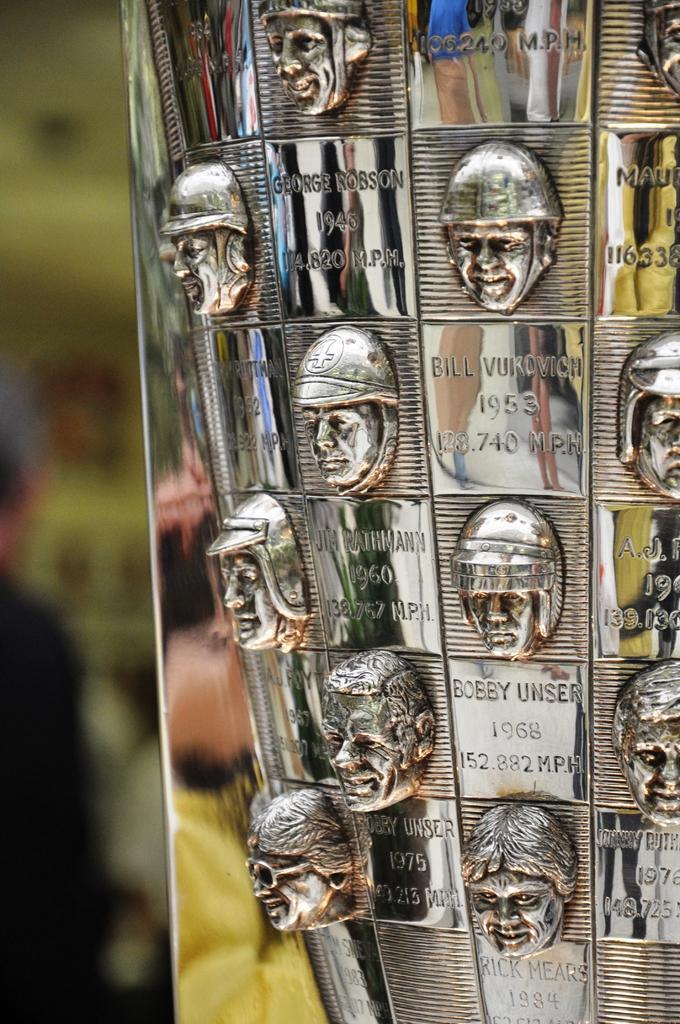How would you summarize this image in a sentence or two? In this image we can see the human faces engraved on a metal surface. 